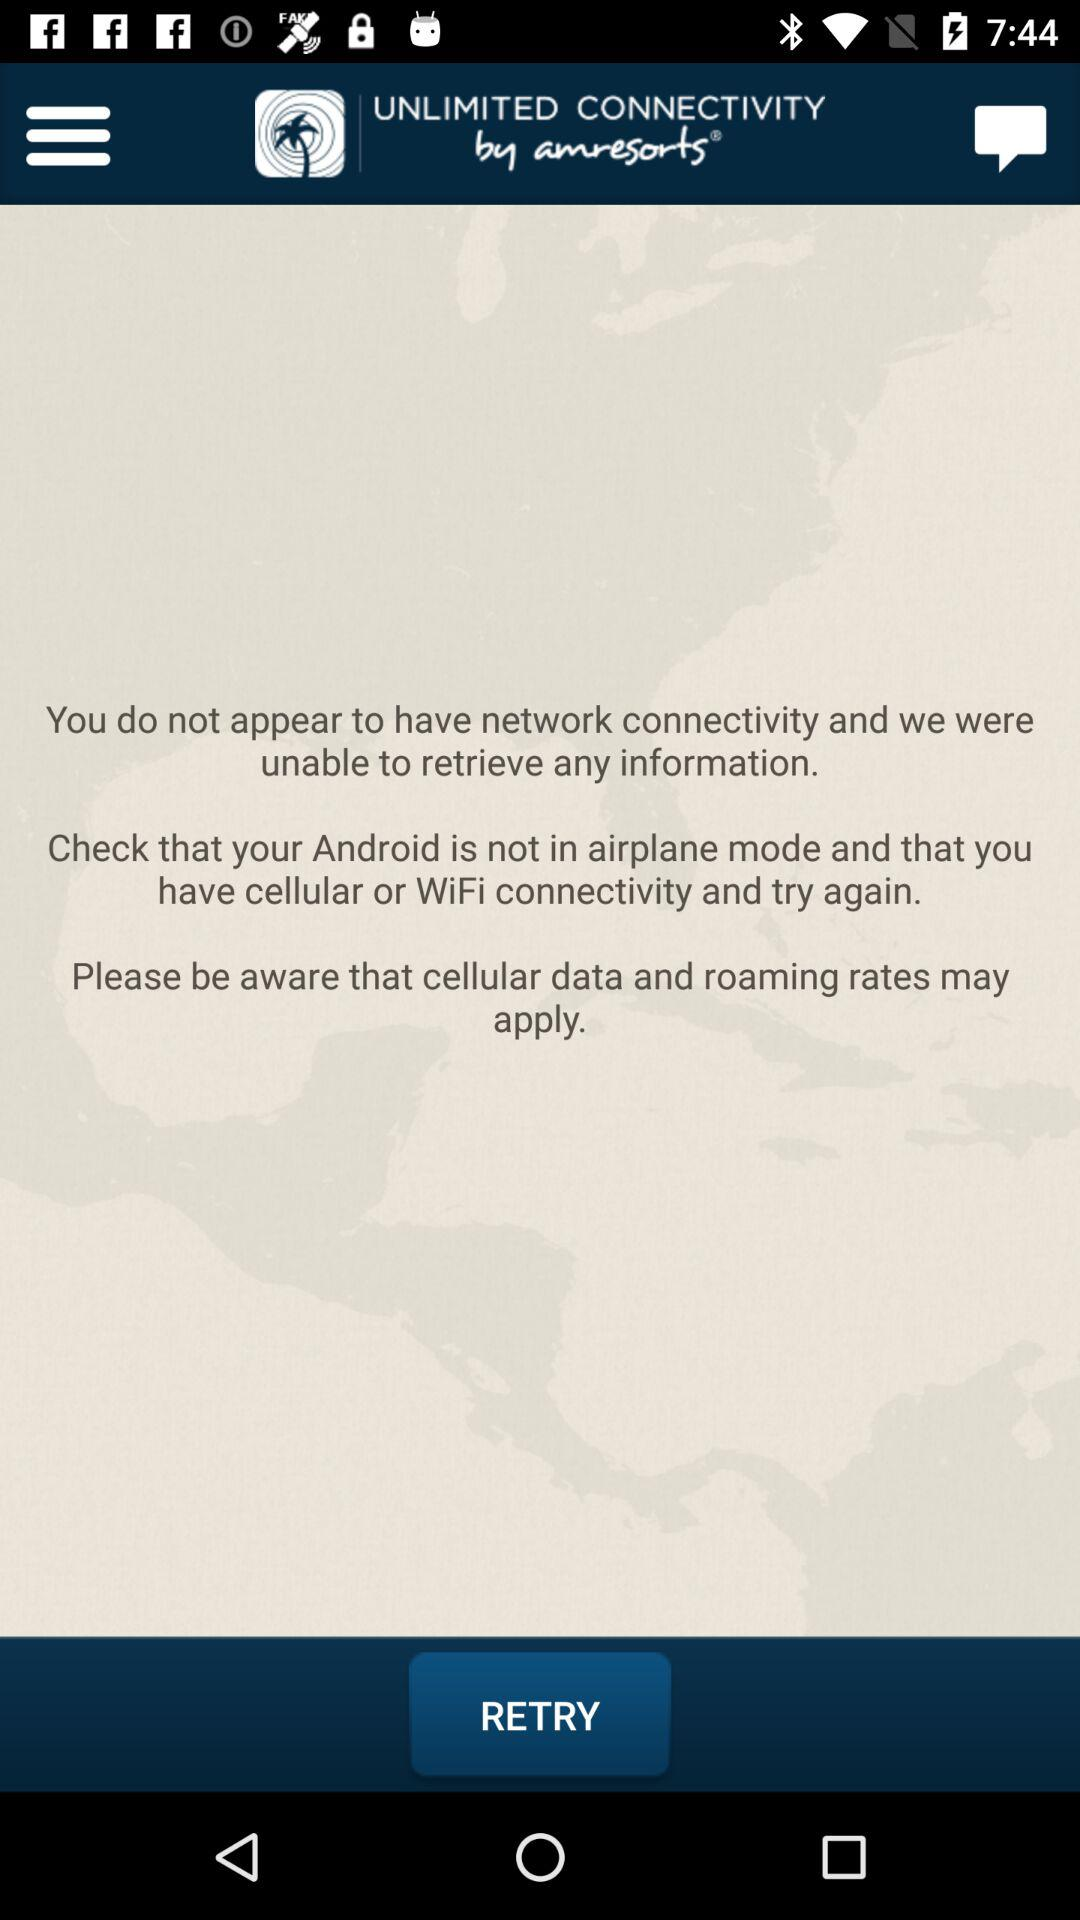How many messages are there on the screen?
Answer the question using a single word or phrase. 3 